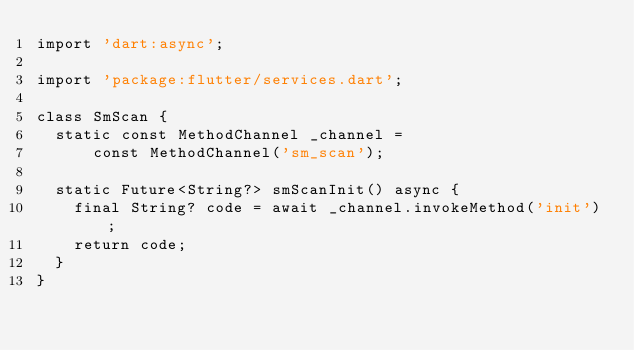Convert code to text. <code><loc_0><loc_0><loc_500><loc_500><_Dart_>import 'dart:async';

import 'package:flutter/services.dart';

class SmScan {
  static const MethodChannel _channel =
      const MethodChannel('sm_scan');

  static Future<String?> smScanInit() async {
    final String? code = await _channel.invokeMethod('init');
    return code;
  }
}
</code> 